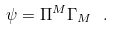<formula> <loc_0><loc_0><loc_500><loc_500>\psi = \Pi ^ { M } \Gamma _ { M } \ .</formula> 